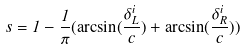<formula> <loc_0><loc_0><loc_500><loc_500>s = 1 - \frac { 1 } { \pi } ( \arcsin ( \frac { \delta _ { L } ^ { i } } { c } ) + \arcsin ( \frac { \delta _ { R } ^ { i } } { c } ) )</formula> 